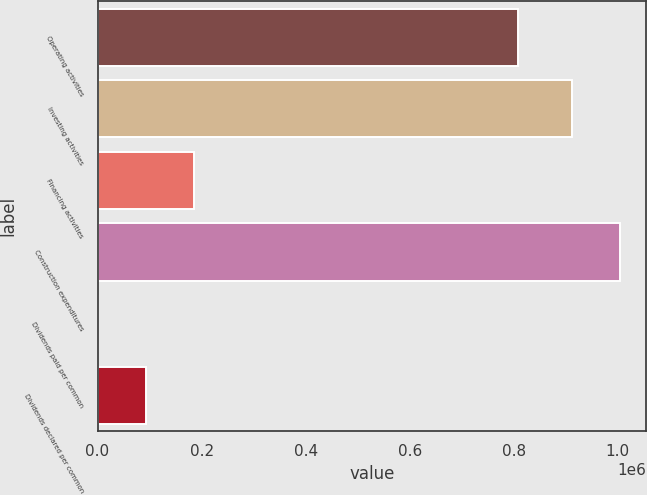Convert chart to OTSL. <chart><loc_0><loc_0><loc_500><loc_500><bar_chart><fcel>Operating activities<fcel>Investing activities<fcel>Financing activities<fcel>Construction expenditures<fcel>Dividends paid per common<fcel>Dividends declared per common<nl><fcel>808357<fcel>912397<fcel>184972<fcel>1.00488e+06<fcel>0.9<fcel>92486.6<nl></chart> 